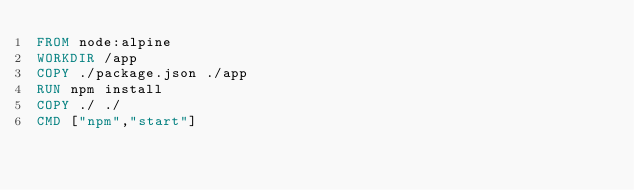Convert code to text. <code><loc_0><loc_0><loc_500><loc_500><_Dockerfile_>FROM node:alpine
WORKDIR /app
COPY ./package.json ./app
RUN npm install
COPY ./ ./
CMD ["npm","start"]</code> 